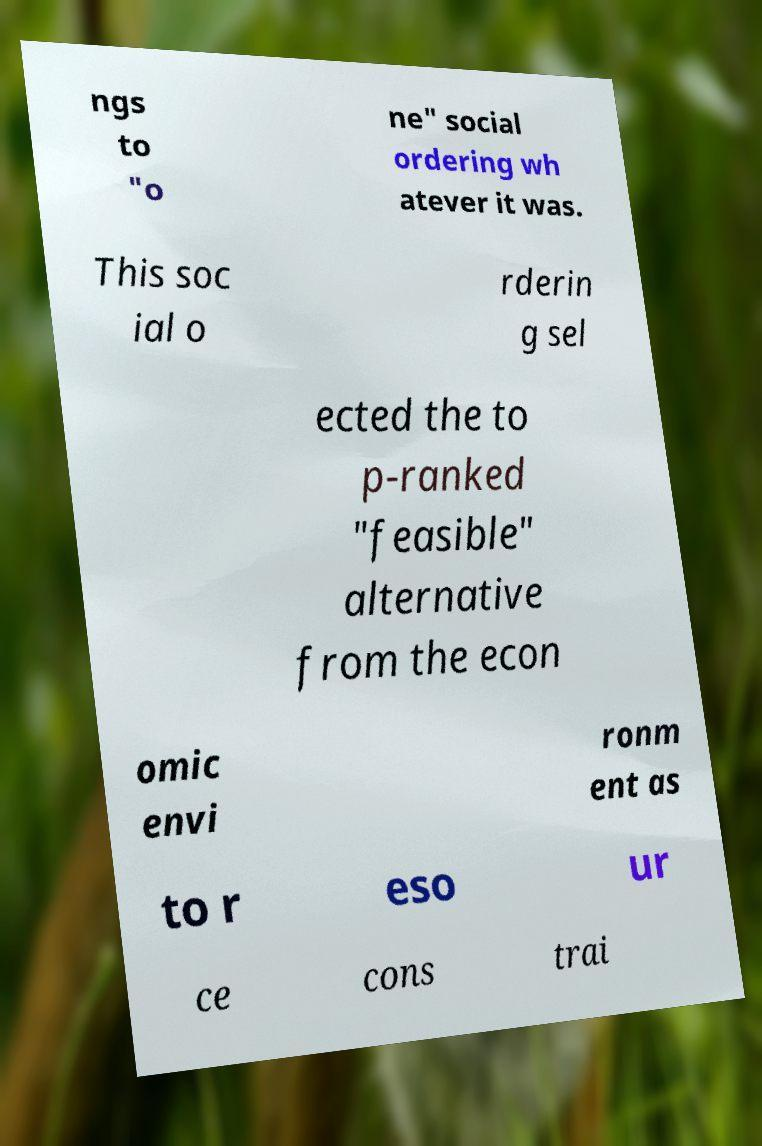Please identify and transcribe the text found in this image. ngs to "o ne" social ordering wh atever it was. This soc ial o rderin g sel ected the to p-ranked "feasible" alternative from the econ omic envi ronm ent as to r eso ur ce cons trai 